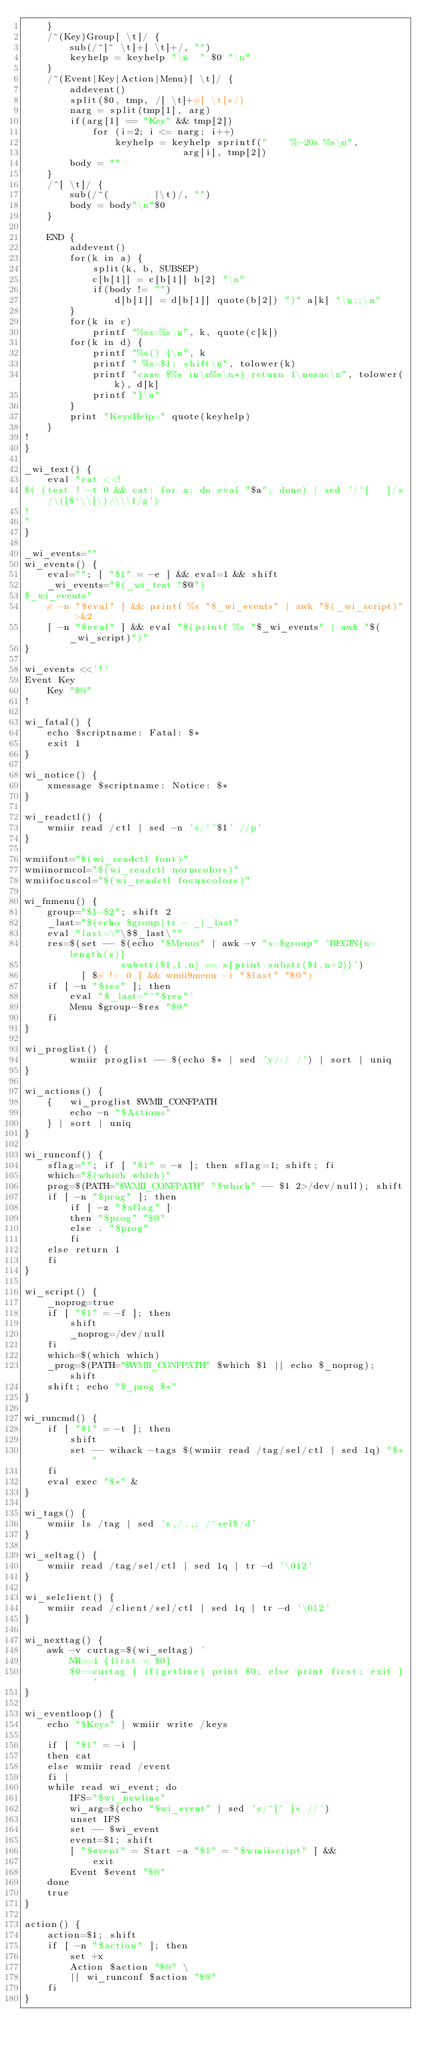Convert code to text. <code><loc_0><loc_0><loc_500><loc_500><_Bash_>	}
	/^(Key)Group[ \t]/ {
		sub(/^[^ \t]+[ \t]+/, "")
		keyhelp = keyhelp "\n  " $0 "\n"
	}
	/^(Event|Key|Action|Menu)[ \t]/ {
		addevent()
		split($0, tmp, /[ \t]+#[ \t]*/)
		narg = split(tmp[1], arg)
		if(arg[1] == "Key" && tmp[2])
			for (i=2; i <= narg; i++)
				keyhelp = keyhelp sprintf("    %-20s %s\n",
					        arg[i], tmp[2])
		body = ""
	}
	/^[ \t]/ {
		sub(/^(        |\t)/, "")
		body = body"\n"$0
	}

	END {
		addevent()
		for(k in a) {
			split(k, b, SUBSEP)
			c[b[1]] = c[b[1]] b[2] "\n"
			if(body != "")
				d[b[1]] = d[b[1]] quote(b[2]) ")" a[k] "\n;;\n"
		}
		for(k in c)
			printf "%ss=%s\n", k, quote(c[k])
		for(k in d) {
			printf "%s() {\n", k
			printf " %s=$1; shift\n", tolower(k)
			printf "case $%s in\n%s\n*) return 1\nesac\n", tolower(k), d[k]
			printf "}\n"
		}
		print "KeysHelp=" quote(keyhelp)
	}
!
}

_wi_text() {
	eval "cat <<!
$( (test ! -t 0 && cat; for a; do eval "$a"; done) | sed '/^[ 	]/s/\([$`\\]\)/\\\1/g')
!
"
}

_wi_events=""
wi_events() {
	eval=""; [ "$1" = -e ] && eval=1 && shift
	_wi_events="$(_wi_text "$@")
$_wi_events"
	# -n "$eval" ] && printf %s "$_wi_events" | awk "$(_wi_script)" >&2
	[ -n "$eval" ] && eval "$(printf %s "$_wi_events" | awk "$(_wi_script)")"
}

wi_events <<'!'
Event Key
	Key "$@"
!

wi_fatal() {
	echo $scriptname: Fatal: $*
	exit 1
}

wi_notice() {
	xmessage $scriptname: Notice: $*
}

wi_readctl() {
	wmiir read /ctl | sed -n 's/^'$1' //p'
}

wmiifont="$(wi_readctl font)"
wmiinormcol="$(wi_readctl normcolors)"
wmiifocuscol="$(wi_readctl focuscolors)"

wi_fnmenu() {
	group="$1-$2"; shift 2
	_last="$(echo $group|tr - _)_last"
	eval "last=\"\$$_last\""
	res=$(set -- $(echo "$Menus" | awk -v "s=$group" 'BEGIN{n=length(s)}
		         substr($1,1,n) == s{print substr($1,n+2)}')
	      [ $# != 0 ] && wmii9menu -i "$last" "$@")
	if [ -n "$res" ]; then
		eval "$_last="'"$res"'
		Menu $group-$res "$@"
	fi
}

wi_proglist() {
        wmiir proglist -- $(echo $* | sed 'y/:/ /') | sort | uniq
}

wi_actions() {
	{	wi_proglist $WMII_CONFPATH
	 	echo -n "$Actions"
	} | sort | uniq
}

wi_runconf() {
	sflag=""; if [ "$1" = -s ]; then sflag=1; shift; fi
	which="$(which which)"
	prog=$(PATH="$WMII_CONFPATH" "$which" -- $1 2>/dev/null); shift
	if [ -n "$prog" ]; then
		if [ -z "$sflag" ]
		then "$prog" "$@"
		else . "$prog"
		fi
	else return 1
	fi
}

wi_script() {
	_noprog=true
	if [ "$1" = -f ]; then
		shift
		_noprog=/dev/null
	fi
	which=$(which which)
	_prog=$(PATH="$WMII_CONFPATH" $which $1 || echo $_noprog); shift
	shift; echo "$_prog $*"
}

wi_runcmd() {
	if [ "$1" = -t ]; then
		shift
		set -- wihack -tags $(wmiir read /tag/sel/ctl | sed 1q) "$*"
	fi
	eval exec "$*" &
}

wi_tags() {
	wmiir ls /tag | sed 's,/,,; /^sel$/d'
}

wi_seltag() {
	wmiir read /tag/sel/ctl | sed 1q | tr -d '\012'
}

wi_selclient() {
	wmiir read /client/sel/ctl | sed 1q | tr -d '\012'
}

wi_nexttag() {
	awk -v curtag=$(wi_seltag) '
		NR==1 {first = $0}
		$0==curtag { if(getline) print $0; else print first; exit }'
}

wi_eventloop() {
	echo "$Keys" | wmiir write /keys

	if [ "$1" = -i ]
	then cat
	else wmiir read /event
	fi |
	while read wi_event; do
		IFS="$wi_newline"
		wi_arg=$(echo "$wi_event" | sed 's/^[^ ]* //')
		unset IFS
		set -- $wi_event
		event=$1; shift
		[ "$event" = Start -a "$1" = "$wmiiscript" ] &&
			exit
		Event $event "$@"
	done
	true
}

action() {
	action=$1; shift
	if [ -n "$action" ]; then
		set +x
		Action $action "$@" \
		|| wi_runconf $action "$@"
	fi
}

</code> 